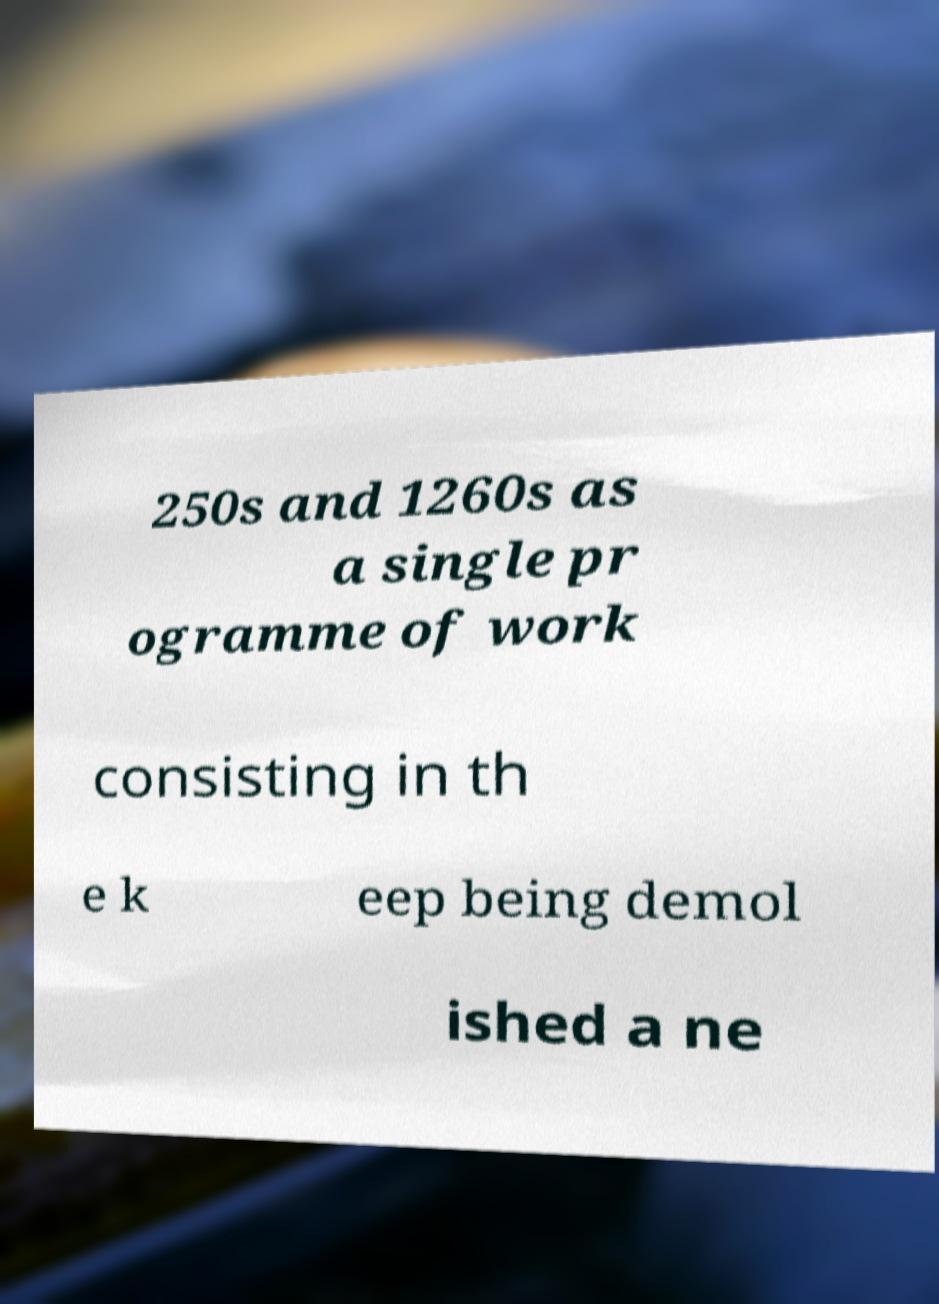Could you extract and type out the text from this image? 250s and 1260s as a single pr ogramme of work consisting in th e k eep being demol ished a ne 